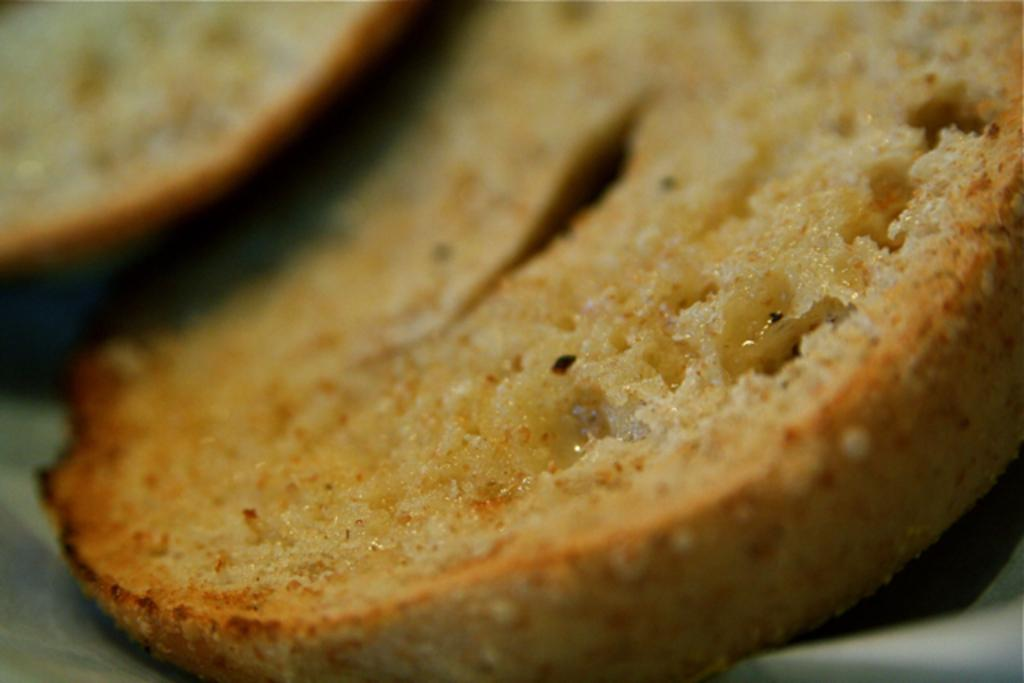What is present on the plate in the image? There are two slices of bread in the image. Can you describe the arrangement of the bread on the plate? The slices of bread are on a plate. What shape is the mist taking in the image? There is no mist present in the image. What type of laborer can be seen working in the image? There are no laborers present in the image. 